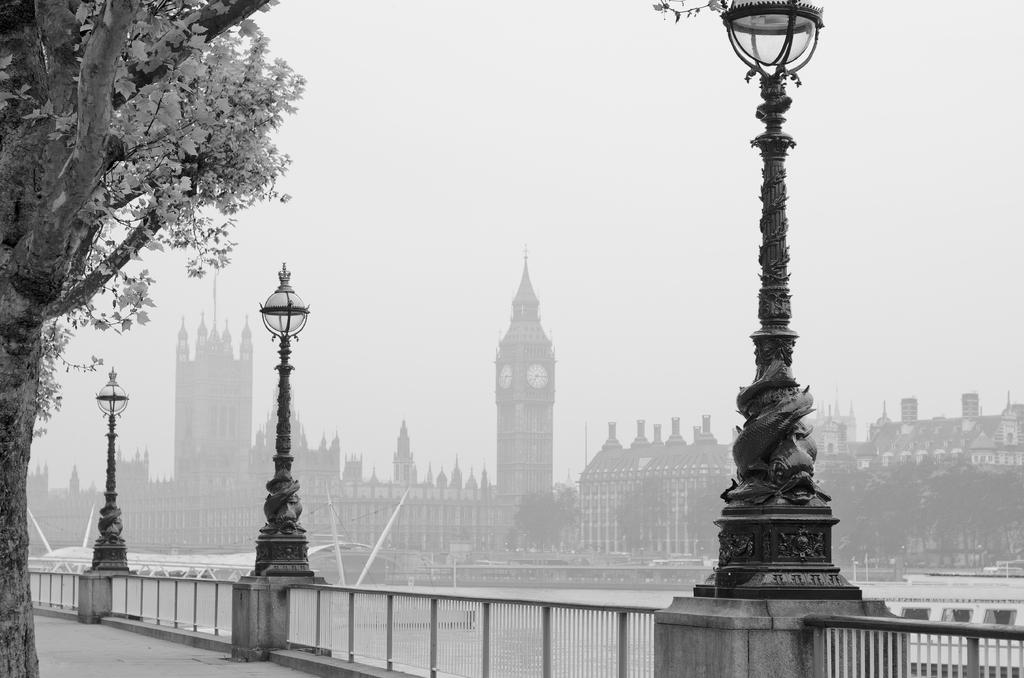What type of vertical structures can be seen in the image? There are light poles in the image. What type of plant is present in the image? There is a tree in the image. What type of barrier is visible in the image? There is a fence in the image. What type of watercraft is above the water in the image? There is a boat above the water in the image. What type of structures can be seen in the background of the image? Buildings, poles, and trees are visible in the background of the image. What part of the natural environment is visible in the background of the image? The sky is visible in the background of the image. What type of soup is being served in the image? There is no soup present in the image. Are there any slaves depicted in the image? There is no reference to slavery or any individuals who might be considered slaves in the image. 